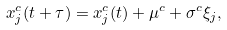<formula> <loc_0><loc_0><loc_500><loc_500>x ^ { c } _ { j } ( t + \tau ) = x ^ { c } _ { j } ( t ) + \mu ^ { c } + \sigma ^ { c } \xi _ { j } ,</formula> 